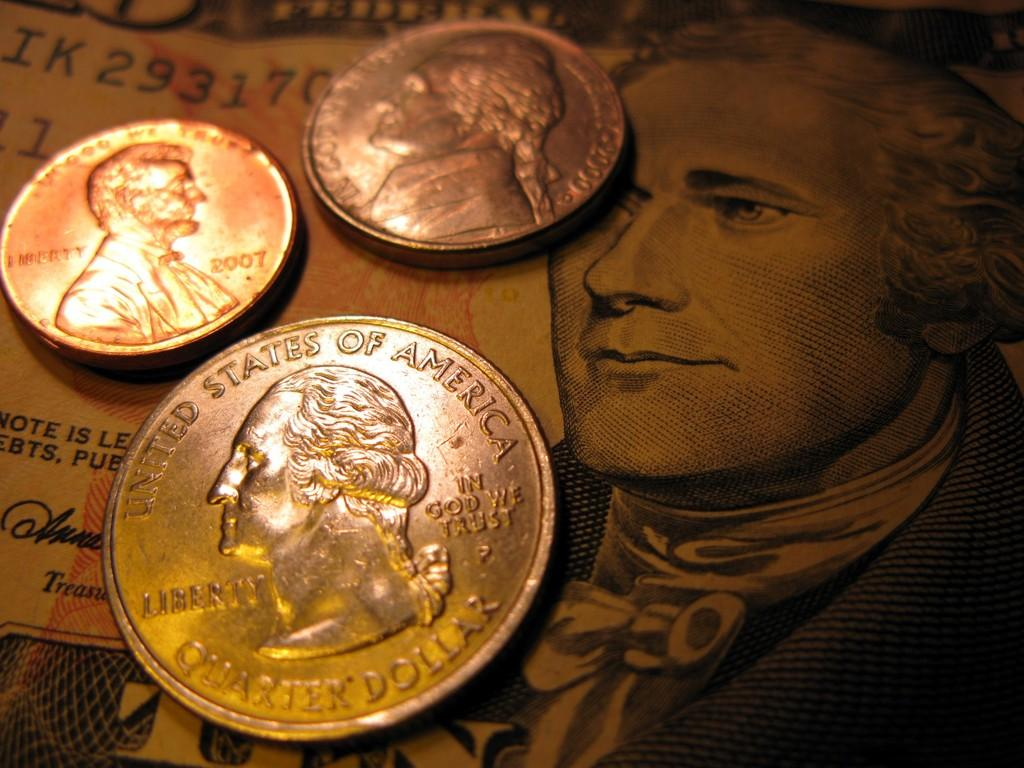<image>
Describe the image concisely. A group of change with United States of America on the quarter piece. 